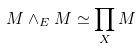<formula> <loc_0><loc_0><loc_500><loc_500>M \wedge _ { E } M \simeq \prod _ { X } M</formula> 